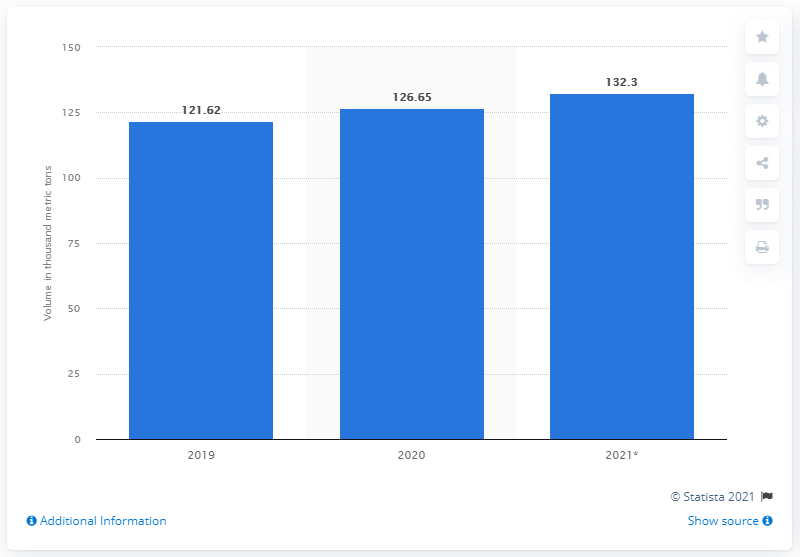Specify some key components in this picture. In 2020, a total of 127 thousand metric tons of avocados were exported to the United States. 